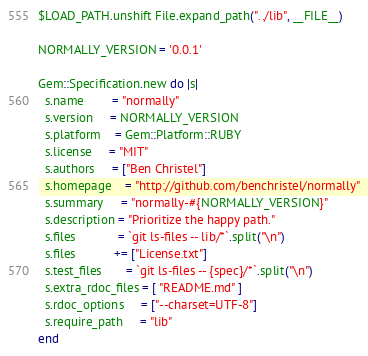Convert code to text. <code><loc_0><loc_0><loc_500><loc_500><_Ruby_>$LOAD_PATH.unshift File.expand_path("../lib", __FILE__)

NORMALLY_VERSION = '0.0.1'

Gem::Specification.new do |s|
  s.name        = "normally"
  s.version     = NORMALLY_VERSION
  s.platform    = Gem::Platform::RUBY
  s.license     = "MIT"
  s.authors     = ["Ben Christel"]
  s.homepage    = "http://github.com/benchristel/normally"
  s.summary     = "normally-#{NORMALLY_VERSION}"
  s.description = "Prioritize the happy path."
  s.files            = `git ls-files -- lib/*`.split("\n")
  s.files           += ["License.txt"]
  s.test_files       = `git ls-files -- {spec}/*`.split("\n")
  s.extra_rdoc_files = [ "README.md" ]
  s.rdoc_options     = ["--charset=UTF-8"]
  s.require_path     = "lib"
end
</code> 